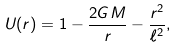Convert formula to latex. <formula><loc_0><loc_0><loc_500><loc_500>U ( r ) = 1 - \frac { 2 G M } { r } - \frac { r ^ { 2 } } { \ell ^ { 2 } } ,</formula> 